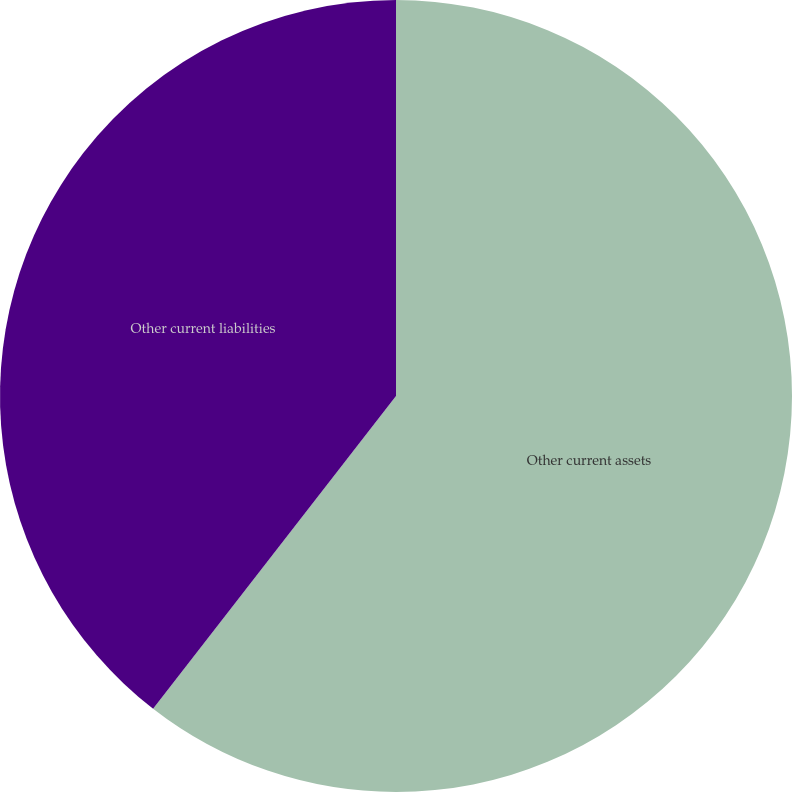<chart> <loc_0><loc_0><loc_500><loc_500><pie_chart><fcel>Other current assets<fcel>Other current liabilities<nl><fcel>60.51%<fcel>39.49%<nl></chart> 